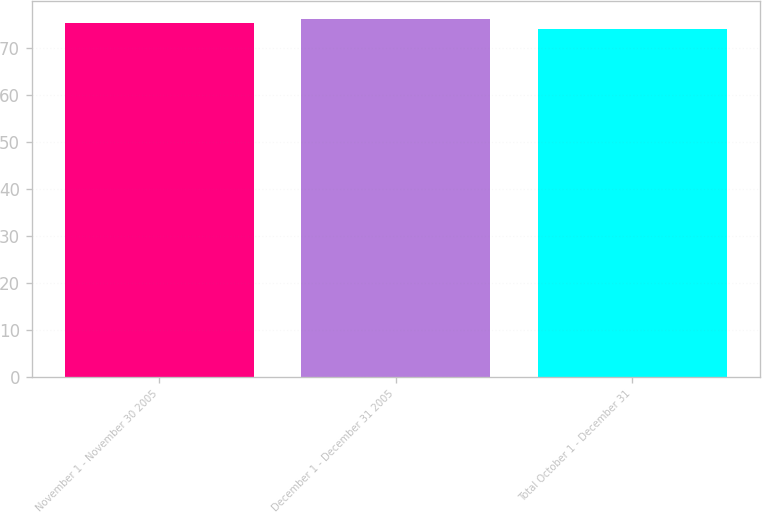Convert chart to OTSL. <chart><loc_0><loc_0><loc_500><loc_500><bar_chart><fcel>November 1 - November 30 2005<fcel>December 1 - December 31 2005<fcel>Total October 1 - December 31<nl><fcel>75.35<fcel>76.17<fcel>74.15<nl></chart> 